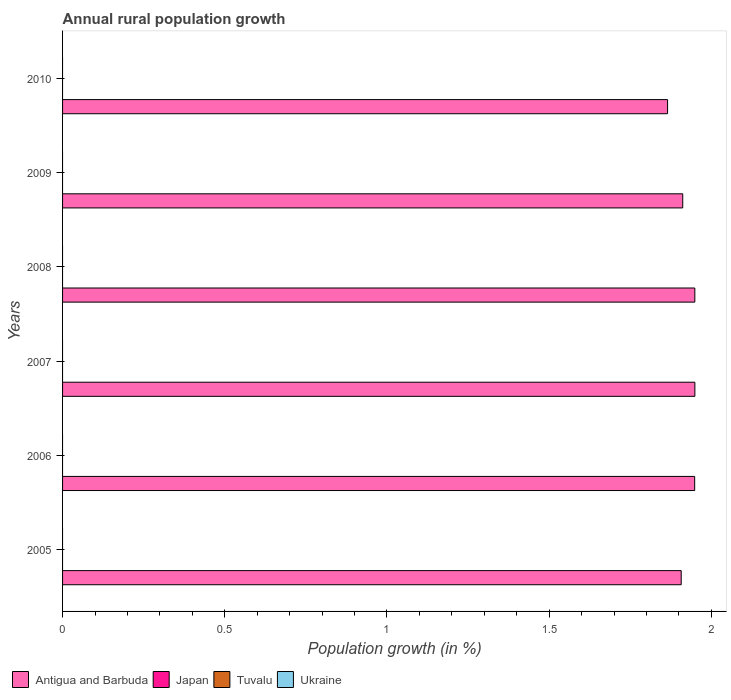Are the number of bars per tick equal to the number of legend labels?
Keep it short and to the point. No. Are the number of bars on each tick of the Y-axis equal?
Ensure brevity in your answer.  Yes. How many bars are there on the 6th tick from the bottom?
Your answer should be very brief. 1. Across all years, what is the maximum percentage of rural population growth in Antigua and Barbuda?
Make the answer very short. 1.95. Across all years, what is the minimum percentage of rural population growth in Tuvalu?
Keep it short and to the point. 0. In which year was the percentage of rural population growth in Antigua and Barbuda maximum?
Keep it short and to the point. 2007. What is the difference between the percentage of rural population growth in Antigua and Barbuda in 2005 and that in 2007?
Ensure brevity in your answer.  -0.04. What is the difference between the percentage of rural population growth in Tuvalu in 2006 and the percentage of rural population growth in Ukraine in 2007?
Provide a short and direct response. 0. What is the ratio of the percentage of rural population growth in Antigua and Barbuda in 2006 to that in 2008?
Keep it short and to the point. 1. Is the percentage of rural population growth in Antigua and Barbuda in 2006 less than that in 2009?
Offer a terse response. No. What is the difference between the highest and the second highest percentage of rural population growth in Antigua and Barbuda?
Provide a short and direct response. 0. Is the sum of the percentage of rural population growth in Antigua and Barbuda in 2008 and 2009 greater than the maximum percentage of rural population growth in Japan across all years?
Give a very brief answer. Yes. How many years are there in the graph?
Give a very brief answer. 6. What is the difference between two consecutive major ticks on the X-axis?
Provide a succinct answer. 0.5. Are the values on the major ticks of X-axis written in scientific E-notation?
Provide a succinct answer. No. How many legend labels are there?
Give a very brief answer. 4. How are the legend labels stacked?
Give a very brief answer. Horizontal. What is the title of the graph?
Keep it short and to the point. Annual rural population growth. Does "Barbados" appear as one of the legend labels in the graph?
Your answer should be compact. No. What is the label or title of the X-axis?
Give a very brief answer. Population growth (in %). What is the label or title of the Y-axis?
Your response must be concise. Years. What is the Population growth (in %) of Antigua and Barbuda in 2005?
Offer a very short reply. 1.91. What is the Population growth (in %) in Ukraine in 2005?
Provide a short and direct response. 0. What is the Population growth (in %) of Antigua and Barbuda in 2006?
Your response must be concise. 1.95. What is the Population growth (in %) of Japan in 2006?
Offer a very short reply. 0. What is the Population growth (in %) in Tuvalu in 2006?
Provide a short and direct response. 0. What is the Population growth (in %) in Antigua and Barbuda in 2007?
Your answer should be compact. 1.95. What is the Population growth (in %) of Antigua and Barbuda in 2008?
Offer a very short reply. 1.95. What is the Population growth (in %) in Tuvalu in 2008?
Ensure brevity in your answer.  0. What is the Population growth (in %) of Antigua and Barbuda in 2009?
Give a very brief answer. 1.91. What is the Population growth (in %) in Antigua and Barbuda in 2010?
Offer a terse response. 1.87. What is the Population growth (in %) of Japan in 2010?
Your answer should be compact. 0. Across all years, what is the maximum Population growth (in %) of Antigua and Barbuda?
Ensure brevity in your answer.  1.95. Across all years, what is the minimum Population growth (in %) in Antigua and Barbuda?
Offer a very short reply. 1.87. What is the total Population growth (in %) in Antigua and Barbuda in the graph?
Your answer should be compact. 11.53. What is the total Population growth (in %) of Ukraine in the graph?
Keep it short and to the point. 0. What is the difference between the Population growth (in %) of Antigua and Barbuda in 2005 and that in 2006?
Offer a terse response. -0.04. What is the difference between the Population growth (in %) of Antigua and Barbuda in 2005 and that in 2007?
Your answer should be compact. -0.04. What is the difference between the Population growth (in %) in Antigua and Barbuda in 2005 and that in 2008?
Provide a short and direct response. -0.04. What is the difference between the Population growth (in %) in Antigua and Barbuda in 2005 and that in 2009?
Offer a terse response. -0. What is the difference between the Population growth (in %) of Antigua and Barbuda in 2005 and that in 2010?
Give a very brief answer. 0.04. What is the difference between the Population growth (in %) of Antigua and Barbuda in 2006 and that in 2007?
Give a very brief answer. -0. What is the difference between the Population growth (in %) in Antigua and Barbuda in 2006 and that in 2008?
Provide a short and direct response. -0. What is the difference between the Population growth (in %) in Antigua and Barbuda in 2006 and that in 2009?
Offer a very short reply. 0.04. What is the difference between the Population growth (in %) of Antigua and Barbuda in 2006 and that in 2010?
Make the answer very short. 0.08. What is the difference between the Population growth (in %) in Antigua and Barbuda in 2007 and that in 2009?
Give a very brief answer. 0.04. What is the difference between the Population growth (in %) of Antigua and Barbuda in 2007 and that in 2010?
Give a very brief answer. 0.08. What is the difference between the Population growth (in %) in Antigua and Barbuda in 2008 and that in 2009?
Provide a succinct answer. 0.04. What is the difference between the Population growth (in %) of Antigua and Barbuda in 2008 and that in 2010?
Your response must be concise. 0.08. What is the difference between the Population growth (in %) of Antigua and Barbuda in 2009 and that in 2010?
Provide a succinct answer. 0.05. What is the average Population growth (in %) in Antigua and Barbuda per year?
Make the answer very short. 1.92. What is the average Population growth (in %) in Tuvalu per year?
Your answer should be very brief. 0. What is the average Population growth (in %) of Ukraine per year?
Offer a terse response. 0. What is the ratio of the Population growth (in %) in Antigua and Barbuda in 2005 to that in 2006?
Provide a short and direct response. 0.98. What is the ratio of the Population growth (in %) in Antigua and Barbuda in 2005 to that in 2007?
Offer a terse response. 0.98. What is the ratio of the Population growth (in %) of Antigua and Barbuda in 2005 to that in 2008?
Provide a short and direct response. 0.98. What is the ratio of the Population growth (in %) of Antigua and Barbuda in 2005 to that in 2010?
Offer a terse response. 1.02. What is the ratio of the Population growth (in %) in Antigua and Barbuda in 2006 to that in 2007?
Ensure brevity in your answer.  1. What is the ratio of the Population growth (in %) in Antigua and Barbuda in 2006 to that in 2008?
Provide a short and direct response. 1. What is the ratio of the Population growth (in %) in Antigua and Barbuda in 2006 to that in 2009?
Your response must be concise. 1.02. What is the ratio of the Population growth (in %) of Antigua and Barbuda in 2006 to that in 2010?
Keep it short and to the point. 1.04. What is the ratio of the Population growth (in %) in Antigua and Barbuda in 2007 to that in 2009?
Offer a terse response. 1.02. What is the ratio of the Population growth (in %) of Antigua and Barbuda in 2007 to that in 2010?
Make the answer very short. 1.05. What is the ratio of the Population growth (in %) of Antigua and Barbuda in 2008 to that in 2009?
Offer a terse response. 1.02. What is the ratio of the Population growth (in %) of Antigua and Barbuda in 2008 to that in 2010?
Make the answer very short. 1.04. What is the ratio of the Population growth (in %) in Antigua and Barbuda in 2009 to that in 2010?
Offer a terse response. 1.03. What is the difference between the highest and the lowest Population growth (in %) in Antigua and Barbuda?
Make the answer very short. 0.08. 